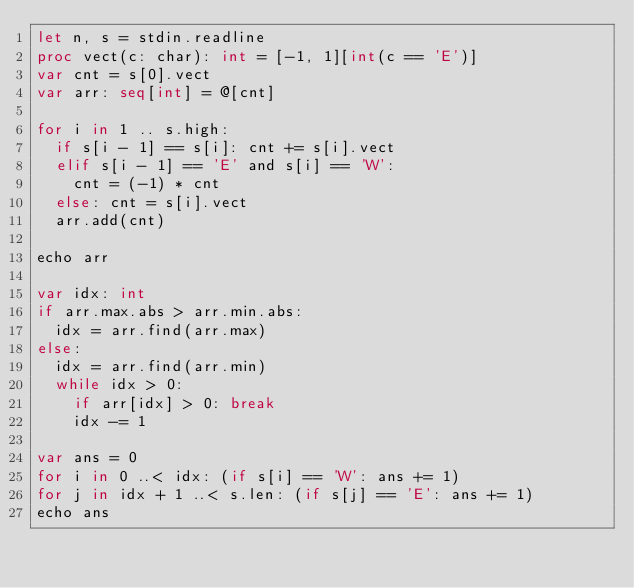Convert code to text. <code><loc_0><loc_0><loc_500><loc_500><_Nim_>let n, s = stdin.readline
proc vect(c: char): int = [-1, 1][int(c == 'E')]
var cnt = s[0].vect
var arr: seq[int] = @[cnt]

for i in 1 .. s.high:
  if s[i - 1] == s[i]: cnt += s[i].vect
  elif s[i - 1] == 'E' and s[i] == 'W':
    cnt = (-1) * cnt
  else: cnt = s[i].vect
  arr.add(cnt)

echo arr

var idx: int
if arr.max.abs > arr.min.abs:
  idx = arr.find(arr.max)
else:
  idx = arr.find(arr.min)
  while idx > 0:
    if arr[idx] > 0: break
    idx -= 1

var ans = 0
for i in 0 ..< idx: (if s[i] == 'W': ans += 1)
for j in idx + 1 ..< s.len: (if s[j] == 'E': ans += 1)
echo ans
</code> 